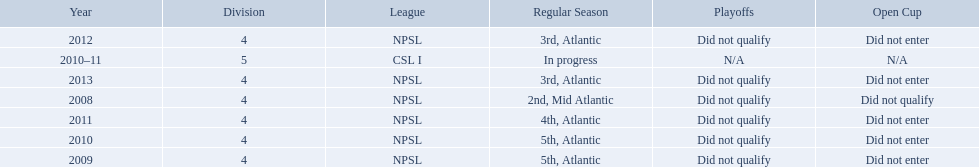What are all of the leagues? NPSL, NPSL, NPSL, CSL I, NPSL, NPSL, NPSL. Which league was played in the least? CSL I. 